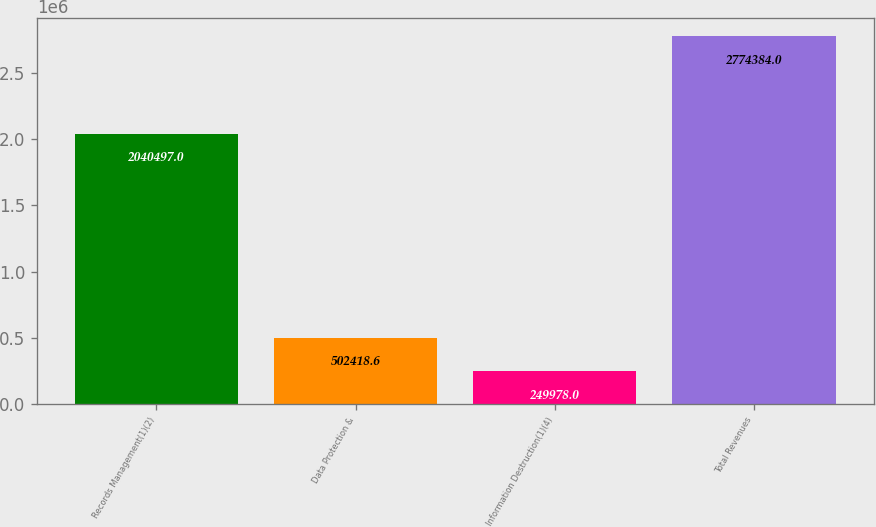<chart> <loc_0><loc_0><loc_500><loc_500><bar_chart><fcel>Records Management(1)(2)<fcel>Data Protection &<fcel>Information Destruction(1)(4)<fcel>Total Revenues<nl><fcel>2.0405e+06<fcel>502419<fcel>249978<fcel>2.77438e+06<nl></chart> 